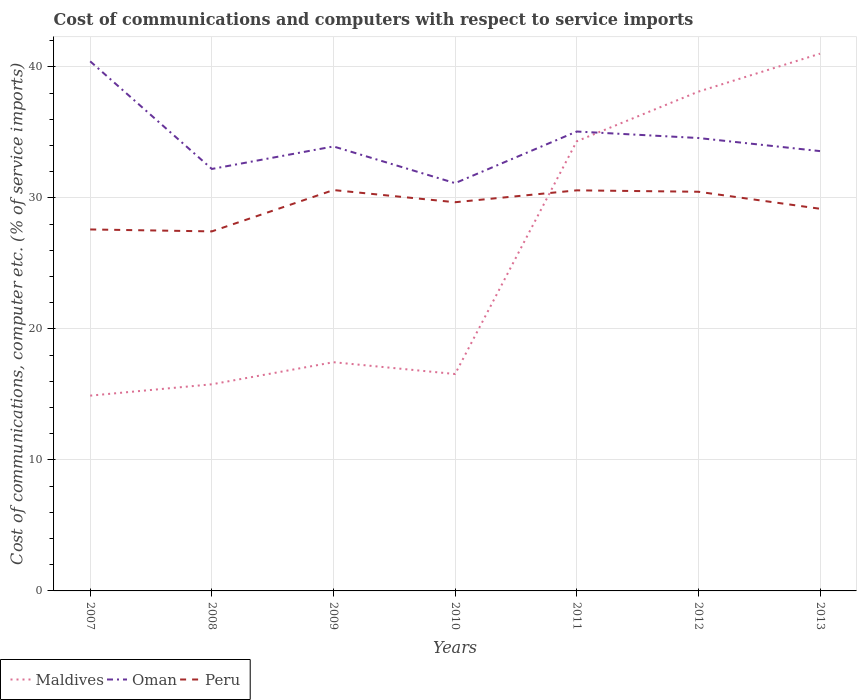Does the line corresponding to Oman intersect with the line corresponding to Maldives?
Offer a very short reply. Yes. Is the number of lines equal to the number of legend labels?
Provide a short and direct response. Yes. Across all years, what is the maximum cost of communications and computers in Oman?
Provide a succinct answer. 31.13. In which year was the cost of communications and computers in Peru maximum?
Keep it short and to the point. 2008. What is the total cost of communications and computers in Maldives in the graph?
Provide a succinct answer. -0.87. What is the difference between the highest and the second highest cost of communications and computers in Peru?
Provide a short and direct response. 3.16. What is the difference between the highest and the lowest cost of communications and computers in Peru?
Keep it short and to the point. 4. Is the cost of communications and computers in Oman strictly greater than the cost of communications and computers in Peru over the years?
Provide a succinct answer. No. How many years are there in the graph?
Offer a very short reply. 7. Does the graph contain grids?
Provide a succinct answer. Yes. Where does the legend appear in the graph?
Ensure brevity in your answer.  Bottom left. How are the legend labels stacked?
Give a very brief answer. Horizontal. What is the title of the graph?
Provide a succinct answer. Cost of communications and computers with respect to service imports. What is the label or title of the X-axis?
Your answer should be very brief. Years. What is the label or title of the Y-axis?
Provide a short and direct response. Cost of communications, computer etc. (% of service imports). What is the Cost of communications, computer etc. (% of service imports) in Maldives in 2007?
Your response must be concise. 14.91. What is the Cost of communications, computer etc. (% of service imports) in Oman in 2007?
Offer a very short reply. 40.43. What is the Cost of communications, computer etc. (% of service imports) of Peru in 2007?
Make the answer very short. 27.59. What is the Cost of communications, computer etc. (% of service imports) in Maldives in 2008?
Ensure brevity in your answer.  15.77. What is the Cost of communications, computer etc. (% of service imports) of Oman in 2008?
Ensure brevity in your answer.  32.21. What is the Cost of communications, computer etc. (% of service imports) in Peru in 2008?
Ensure brevity in your answer.  27.45. What is the Cost of communications, computer etc. (% of service imports) of Maldives in 2009?
Make the answer very short. 17.46. What is the Cost of communications, computer etc. (% of service imports) in Oman in 2009?
Your answer should be compact. 33.93. What is the Cost of communications, computer etc. (% of service imports) of Peru in 2009?
Your answer should be very brief. 30.6. What is the Cost of communications, computer etc. (% of service imports) of Maldives in 2010?
Keep it short and to the point. 16.56. What is the Cost of communications, computer etc. (% of service imports) in Oman in 2010?
Offer a terse response. 31.13. What is the Cost of communications, computer etc. (% of service imports) in Peru in 2010?
Make the answer very short. 29.67. What is the Cost of communications, computer etc. (% of service imports) in Maldives in 2011?
Your answer should be compact. 34.33. What is the Cost of communications, computer etc. (% of service imports) of Oman in 2011?
Your answer should be compact. 35.07. What is the Cost of communications, computer etc. (% of service imports) of Peru in 2011?
Provide a short and direct response. 30.58. What is the Cost of communications, computer etc. (% of service imports) of Maldives in 2012?
Offer a very short reply. 38.11. What is the Cost of communications, computer etc. (% of service imports) in Oman in 2012?
Offer a very short reply. 34.57. What is the Cost of communications, computer etc. (% of service imports) of Peru in 2012?
Make the answer very short. 30.47. What is the Cost of communications, computer etc. (% of service imports) of Maldives in 2013?
Offer a very short reply. 41.01. What is the Cost of communications, computer etc. (% of service imports) in Oman in 2013?
Ensure brevity in your answer.  33.58. What is the Cost of communications, computer etc. (% of service imports) of Peru in 2013?
Ensure brevity in your answer.  29.17. Across all years, what is the maximum Cost of communications, computer etc. (% of service imports) in Maldives?
Keep it short and to the point. 41.01. Across all years, what is the maximum Cost of communications, computer etc. (% of service imports) of Oman?
Your response must be concise. 40.43. Across all years, what is the maximum Cost of communications, computer etc. (% of service imports) of Peru?
Offer a terse response. 30.6. Across all years, what is the minimum Cost of communications, computer etc. (% of service imports) in Maldives?
Make the answer very short. 14.91. Across all years, what is the minimum Cost of communications, computer etc. (% of service imports) in Oman?
Give a very brief answer. 31.13. Across all years, what is the minimum Cost of communications, computer etc. (% of service imports) in Peru?
Your answer should be compact. 27.45. What is the total Cost of communications, computer etc. (% of service imports) in Maldives in the graph?
Your response must be concise. 178.15. What is the total Cost of communications, computer etc. (% of service imports) in Oman in the graph?
Ensure brevity in your answer.  240.92. What is the total Cost of communications, computer etc. (% of service imports) in Peru in the graph?
Ensure brevity in your answer.  205.54. What is the difference between the Cost of communications, computer etc. (% of service imports) of Maldives in 2007 and that in 2008?
Provide a short and direct response. -0.87. What is the difference between the Cost of communications, computer etc. (% of service imports) of Oman in 2007 and that in 2008?
Keep it short and to the point. 8.22. What is the difference between the Cost of communications, computer etc. (% of service imports) in Peru in 2007 and that in 2008?
Provide a short and direct response. 0.15. What is the difference between the Cost of communications, computer etc. (% of service imports) in Maldives in 2007 and that in 2009?
Provide a short and direct response. -2.55. What is the difference between the Cost of communications, computer etc. (% of service imports) in Oman in 2007 and that in 2009?
Offer a very short reply. 6.5. What is the difference between the Cost of communications, computer etc. (% of service imports) of Peru in 2007 and that in 2009?
Make the answer very short. -3.01. What is the difference between the Cost of communications, computer etc. (% of service imports) in Maldives in 2007 and that in 2010?
Keep it short and to the point. -1.65. What is the difference between the Cost of communications, computer etc. (% of service imports) in Oman in 2007 and that in 2010?
Offer a very short reply. 9.3. What is the difference between the Cost of communications, computer etc. (% of service imports) of Peru in 2007 and that in 2010?
Your response must be concise. -2.08. What is the difference between the Cost of communications, computer etc. (% of service imports) in Maldives in 2007 and that in 2011?
Keep it short and to the point. -19.42. What is the difference between the Cost of communications, computer etc. (% of service imports) in Oman in 2007 and that in 2011?
Give a very brief answer. 5.36. What is the difference between the Cost of communications, computer etc. (% of service imports) in Peru in 2007 and that in 2011?
Offer a terse response. -2.98. What is the difference between the Cost of communications, computer etc. (% of service imports) in Maldives in 2007 and that in 2012?
Keep it short and to the point. -23.21. What is the difference between the Cost of communications, computer etc. (% of service imports) of Oman in 2007 and that in 2012?
Ensure brevity in your answer.  5.85. What is the difference between the Cost of communications, computer etc. (% of service imports) of Peru in 2007 and that in 2012?
Keep it short and to the point. -2.88. What is the difference between the Cost of communications, computer etc. (% of service imports) of Maldives in 2007 and that in 2013?
Give a very brief answer. -26.11. What is the difference between the Cost of communications, computer etc. (% of service imports) of Oman in 2007 and that in 2013?
Offer a terse response. 6.85. What is the difference between the Cost of communications, computer etc. (% of service imports) in Peru in 2007 and that in 2013?
Your answer should be very brief. -1.58. What is the difference between the Cost of communications, computer etc. (% of service imports) in Maldives in 2008 and that in 2009?
Make the answer very short. -1.69. What is the difference between the Cost of communications, computer etc. (% of service imports) in Oman in 2008 and that in 2009?
Provide a short and direct response. -1.72. What is the difference between the Cost of communications, computer etc. (% of service imports) in Peru in 2008 and that in 2009?
Provide a short and direct response. -3.16. What is the difference between the Cost of communications, computer etc. (% of service imports) of Maldives in 2008 and that in 2010?
Ensure brevity in your answer.  -0.78. What is the difference between the Cost of communications, computer etc. (% of service imports) in Peru in 2008 and that in 2010?
Your response must be concise. -2.23. What is the difference between the Cost of communications, computer etc. (% of service imports) in Maldives in 2008 and that in 2011?
Offer a very short reply. -18.55. What is the difference between the Cost of communications, computer etc. (% of service imports) in Oman in 2008 and that in 2011?
Keep it short and to the point. -2.86. What is the difference between the Cost of communications, computer etc. (% of service imports) in Peru in 2008 and that in 2011?
Ensure brevity in your answer.  -3.13. What is the difference between the Cost of communications, computer etc. (% of service imports) in Maldives in 2008 and that in 2012?
Your answer should be very brief. -22.34. What is the difference between the Cost of communications, computer etc. (% of service imports) of Oman in 2008 and that in 2012?
Provide a short and direct response. -2.36. What is the difference between the Cost of communications, computer etc. (% of service imports) of Peru in 2008 and that in 2012?
Your answer should be compact. -3.03. What is the difference between the Cost of communications, computer etc. (% of service imports) of Maldives in 2008 and that in 2013?
Keep it short and to the point. -25.24. What is the difference between the Cost of communications, computer etc. (% of service imports) in Oman in 2008 and that in 2013?
Your response must be concise. -1.36. What is the difference between the Cost of communications, computer etc. (% of service imports) of Peru in 2008 and that in 2013?
Your answer should be compact. -1.73. What is the difference between the Cost of communications, computer etc. (% of service imports) in Maldives in 2009 and that in 2010?
Provide a succinct answer. 0.9. What is the difference between the Cost of communications, computer etc. (% of service imports) in Oman in 2009 and that in 2010?
Your response must be concise. 2.8. What is the difference between the Cost of communications, computer etc. (% of service imports) in Peru in 2009 and that in 2010?
Make the answer very short. 0.93. What is the difference between the Cost of communications, computer etc. (% of service imports) of Maldives in 2009 and that in 2011?
Your response must be concise. -16.87. What is the difference between the Cost of communications, computer etc. (% of service imports) in Oman in 2009 and that in 2011?
Your answer should be very brief. -1.14. What is the difference between the Cost of communications, computer etc. (% of service imports) of Peru in 2009 and that in 2011?
Provide a short and direct response. 0.02. What is the difference between the Cost of communications, computer etc. (% of service imports) in Maldives in 2009 and that in 2012?
Your response must be concise. -20.66. What is the difference between the Cost of communications, computer etc. (% of service imports) of Oman in 2009 and that in 2012?
Make the answer very short. -0.64. What is the difference between the Cost of communications, computer etc. (% of service imports) in Peru in 2009 and that in 2012?
Make the answer very short. 0.13. What is the difference between the Cost of communications, computer etc. (% of service imports) in Maldives in 2009 and that in 2013?
Ensure brevity in your answer.  -23.55. What is the difference between the Cost of communications, computer etc. (% of service imports) of Oman in 2009 and that in 2013?
Your response must be concise. 0.36. What is the difference between the Cost of communications, computer etc. (% of service imports) of Peru in 2009 and that in 2013?
Provide a succinct answer. 1.43. What is the difference between the Cost of communications, computer etc. (% of service imports) in Maldives in 2010 and that in 2011?
Offer a very short reply. -17.77. What is the difference between the Cost of communications, computer etc. (% of service imports) of Oman in 2010 and that in 2011?
Your answer should be compact. -3.94. What is the difference between the Cost of communications, computer etc. (% of service imports) of Peru in 2010 and that in 2011?
Offer a terse response. -0.91. What is the difference between the Cost of communications, computer etc. (% of service imports) in Maldives in 2010 and that in 2012?
Ensure brevity in your answer.  -21.56. What is the difference between the Cost of communications, computer etc. (% of service imports) of Oman in 2010 and that in 2012?
Offer a terse response. -3.45. What is the difference between the Cost of communications, computer etc. (% of service imports) in Peru in 2010 and that in 2012?
Your answer should be compact. -0.8. What is the difference between the Cost of communications, computer etc. (% of service imports) in Maldives in 2010 and that in 2013?
Ensure brevity in your answer.  -24.45. What is the difference between the Cost of communications, computer etc. (% of service imports) of Oman in 2010 and that in 2013?
Your response must be concise. -2.45. What is the difference between the Cost of communications, computer etc. (% of service imports) in Peru in 2010 and that in 2013?
Offer a terse response. 0.5. What is the difference between the Cost of communications, computer etc. (% of service imports) of Maldives in 2011 and that in 2012?
Provide a short and direct response. -3.79. What is the difference between the Cost of communications, computer etc. (% of service imports) in Oman in 2011 and that in 2012?
Keep it short and to the point. 0.5. What is the difference between the Cost of communications, computer etc. (% of service imports) of Peru in 2011 and that in 2012?
Your answer should be very brief. 0.11. What is the difference between the Cost of communications, computer etc. (% of service imports) of Maldives in 2011 and that in 2013?
Offer a very short reply. -6.69. What is the difference between the Cost of communications, computer etc. (% of service imports) in Oman in 2011 and that in 2013?
Ensure brevity in your answer.  1.49. What is the difference between the Cost of communications, computer etc. (% of service imports) in Peru in 2011 and that in 2013?
Your answer should be very brief. 1.41. What is the difference between the Cost of communications, computer etc. (% of service imports) in Maldives in 2012 and that in 2013?
Make the answer very short. -2.9. What is the difference between the Cost of communications, computer etc. (% of service imports) in Oman in 2012 and that in 2013?
Provide a short and direct response. 1. What is the difference between the Cost of communications, computer etc. (% of service imports) of Peru in 2012 and that in 2013?
Your answer should be compact. 1.3. What is the difference between the Cost of communications, computer etc. (% of service imports) of Maldives in 2007 and the Cost of communications, computer etc. (% of service imports) of Oman in 2008?
Your answer should be very brief. -17.3. What is the difference between the Cost of communications, computer etc. (% of service imports) of Maldives in 2007 and the Cost of communications, computer etc. (% of service imports) of Peru in 2008?
Offer a very short reply. -12.54. What is the difference between the Cost of communications, computer etc. (% of service imports) of Oman in 2007 and the Cost of communications, computer etc. (% of service imports) of Peru in 2008?
Make the answer very short. 12.98. What is the difference between the Cost of communications, computer etc. (% of service imports) of Maldives in 2007 and the Cost of communications, computer etc. (% of service imports) of Oman in 2009?
Your answer should be compact. -19.02. What is the difference between the Cost of communications, computer etc. (% of service imports) of Maldives in 2007 and the Cost of communications, computer etc. (% of service imports) of Peru in 2009?
Offer a very short reply. -15.69. What is the difference between the Cost of communications, computer etc. (% of service imports) of Oman in 2007 and the Cost of communications, computer etc. (% of service imports) of Peru in 2009?
Your answer should be compact. 9.83. What is the difference between the Cost of communications, computer etc. (% of service imports) in Maldives in 2007 and the Cost of communications, computer etc. (% of service imports) in Oman in 2010?
Keep it short and to the point. -16.22. What is the difference between the Cost of communications, computer etc. (% of service imports) in Maldives in 2007 and the Cost of communications, computer etc. (% of service imports) in Peru in 2010?
Make the answer very short. -14.76. What is the difference between the Cost of communications, computer etc. (% of service imports) in Oman in 2007 and the Cost of communications, computer etc. (% of service imports) in Peru in 2010?
Offer a terse response. 10.76. What is the difference between the Cost of communications, computer etc. (% of service imports) of Maldives in 2007 and the Cost of communications, computer etc. (% of service imports) of Oman in 2011?
Keep it short and to the point. -20.16. What is the difference between the Cost of communications, computer etc. (% of service imports) in Maldives in 2007 and the Cost of communications, computer etc. (% of service imports) in Peru in 2011?
Make the answer very short. -15.67. What is the difference between the Cost of communications, computer etc. (% of service imports) of Oman in 2007 and the Cost of communications, computer etc. (% of service imports) of Peru in 2011?
Your answer should be compact. 9.85. What is the difference between the Cost of communications, computer etc. (% of service imports) in Maldives in 2007 and the Cost of communications, computer etc. (% of service imports) in Oman in 2012?
Offer a terse response. -19.67. What is the difference between the Cost of communications, computer etc. (% of service imports) in Maldives in 2007 and the Cost of communications, computer etc. (% of service imports) in Peru in 2012?
Make the answer very short. -15.56. What is the difference between the Cost of communications, computer etc. (% of service imports) of Oman in 2007 and the Cost of communications, computer etc. (% of service imports) of Peru in 2012?
Provide a short and direct response. 9.96. What is the difference between the Cost of communications, computer etc. (% of service imports) of Maldives in 2007 and the Cost of communications, computer etc. (% of service imports) of Oman in 2013?
Keep it short and to the point. -18.67. What is the difference between the Cost of communications, computer etc. (% of service imports) in Maldives in 2007 and the Cost of communications, computer etc. (% of service imports) in Peru in 2013?
Give a very brief answer. -14.27. What is the difference between the Cost of communications, computer etc. (% of service imports) in Oman in 2007 and the Cost of communications, computer etc. (% of service imports) in Peru in 2013?
Offer a terse response. 11.26. What is the difference between the Cost of communications, computer etc. (% of service imports) of Maldives in 2008 and the Cost of communications, computer etc. (% of service imports) of Oman in 2009?
Make the answer very short. -18.16. What is the difference between the Cost of communications, computer etc. (% of service imports) in Maldives in 2008 and the Cost of communications, computer etc. (% of service imports) in Peru in 2009?
Ensure brevity in your answer.  -14.83. What is the difference between the Cost of communications, computer etc. (% of service imports) of Oman in 2008 and the Cost of communications, computer etc. (% of service imports) of Peru in 2009?
Make the answer very short. 1.61. What is the difference between the Cost of communications, computer etc. (% of service imports) of Maldives in 2008 and the Cost of communications, computer etc. (% of service imports) of Oman in 2010?
Provide a short and direct response. -15.36. What is the difference between the Cost of communications, computer etc. (% of service imports) of Maldives in 2008 and the Cost of communications, computer etc. (% of service imports) of Peru in 2010?
Make the answer very short. -13.9. What is the difference between the Cost of communications, computer etc. (% of service imports) of Oman in 2008 and the Cost of communications, computer etc. (% of service imports) of Peru in 2010?
Provide a short and direct response. 2.54. What is the difference between the Cost of communications, computer etc. (% of service imports) in Maldives in 2008 and the Cost of communications, computer etc. (% of service imports) in Oman in 2011?
Your answer should be very brief. -19.3. What is the difference between the Cost of communications, computer etc. (% of service imports) in Maldives in 2008 and the Cost of communications, computer etc. (% of service imports) in Peru in 2011?
Give a very brief answer. -14.81. What is the difference between the Cost of communications, computer etc. (% of service imports) of Oman in 2008 and the Cost of communications, computer etc. (% of service imports) of Peru in 2011?
Give a very brief answer. 1.63. What is the difference between the Cost of communications, computer etc. (% of service imports) of Maldives in 2008 and the Cost of communications, computer etc. (% of service imports) of Oman in 2012?
Your response must be concise. -18.8. What is the difference between the Cost of communications, computer etc. (% of service imports) in Maldives in 2008 and the Cost of communications, computer etc. (% of service imports) in Peru in 2012?
Your answer should be compact. -14.7. What is the difference between the Cost of communications, computer etc. (% of service imports) of Oman in 2008 and the Cost of communications, computer etc. (% of service imports) of Peru in 2012?
Provide a short and direct response. 1.74. What is the difference between the Cost of communications, computer etc. (% of service imports) of Maldives in 2008 and the Cost of communications, computer etc. (% of service imports) of Oman in 2013?
Your response must be concise. -17.8. What is the difference between the Cost of communications, computer etc. (% of service imports) in Maldives in 2008 and the Cost of communications, computer etc. (% of service imports) in Peru in 2013?
Give a very brief answer. -13.4. What is the difference between the Cost of communications, computer etc. (% of service imports) of Oman in 2008 and the Cost of communications, computer etc. (% of service imports) of Peru in 2013?
Your answer should be compact. 3.04. What is the difference between the Cost of communications, computer etc. (% of service imports) in Maldives in 2009 and the Cost of communications, computer etc. (% of service imports) in Oman in 2010?
Provide a short and direct response. -13.67. What is the difference between the Cost of communications, computer etc. (% of service imports) of Maldives in 2009 and the Cost of communications, computer etc. (% of service imports) of Peru in 2010?
Your answer should be very brief. -12.21. What is the difference between the Cost of communications, computer etc. (% of service imports) of Oman in 2009 and the Cost of communications, computer etc. (% of service imports) of Peru in 2010?
Give a very brief answer. 4.26. What is the difference between the Cost of communications, computer etc. (% of service imports) in Maldives in 2009 and the Cost of communications, computer etc. (% of service imports) in Oman in 2011?
Ensure brevity in your answer.  -17.61. What is the difference between the Cost of communications, computer etc. (% of service imports) of Maldives in 2009 and the Cost of communications, computer etc. (% of service imports) of Peru in 2011?
Ensure brevity in your answer.  -13.12. What is the difference between the Cost of communications, computer etc. (% of service imports) of Oman in 2009 and the Cost of communications, computer etc. (% of service imports) of Peru in 2011?
Keep it short and to the point. 3.35. What is the difference between the Cost of communications, computer etc. (% of service imports) in Maldives in 2009 and the Cost of communications, computer etc. (% of service imports) in Oman in 2012?
Provide a short and direct response. -17.12. What is the difference between the Cost of communications, computer etc. (% of service imports) in Maldives in 2009 and the Cost of communications, computer etc. (% of service imports) in Peru in 2012?
Offer a terse response. -13.01. What is the difference between the Cost of communications, computer etc. (% of service imports) in Oman in 2009 and the Cost of communications, computer etc. (% of service imports) in Peru in 2012?
Ensure brevity in your answer.  3.46. What is the difference between the Cost of communications, computer etc. (% of service imports) in Maldives in 2009 and the Cost of communications, computer etc. (% of service imports) in Oman in 2013?
Your response must be concise. -16.12. What is the difference between the Cost of communications, computer etc. (% of service imports) in Maldives in 2009 and the Cost of communications, computer etc. (% of service imports) in Peru in 2013?
Provide a succinct answer. -11.71. What is the difference between the Cost of communications, computer etc. (% of service imports) in Oman in 2009 and the Cost of communications, computer etc. (% of service imports) in Peru in 2013?
Make the answer very short. 4.76. What is the difference between the Cost of communications, computer etc. (% of service imports) in Maldives in 2010 and the Cost of communications, computer etc. (% of service imports) in Oman in 2011?
Offer a terse response. -18.51. What is the difference between the Cost of communications, computer etc. (% of service imports) in Maldives in 2010 and the Cost of communications, computer etc. (% of service imports) in Peru in 2011?
Provide a short and direct response. -14.02. What is the difference between the Cost of communications, computer etc. (% of service imports) of Oman in 2010 and the Cost of communications, computer etc. (% of service imports) of Peru in 2011?
Your answer should be compact. 0.55. What is the difference between the Cost of communications, computer etc. (% of service imports) of Maldives in 2010 and the Cost of communications, computer etc. (% of service imports) of Oman in 2012?
Make the answer very short. -18.02. What is the difference between the Cost of communications, computer etc. (% of service imports) in Maldives in 2010 and the Cost of communications, computer etc. (% of service imports) in Peru in 2012?
Keep it short and to the point. -13.91. What is the difference between the Cost of communications, computer etc. (% of service imports) in Oman in 2010 and the Cost of communications, computer etc. (% of service imports) in Peru in 2012?
Your response must be concise. 0.66. What is the difference between the Cost of communications, computer etc. (% of service imports) in Maldives in 2010 and the Cost of communications, computer etc. (% of service imports) in Oman in 2013?
Keep it short and to the point. -17.02. What is the difference between the Cost of communications, computer etc. (% of service imports) of Maldives in 2010 and the Cost of communications, computer etc. (% of service imports) of Peru in 2013?
Your answer should be very brief. -12.62. What is the difference between the Cost of communications, computer etc. (% of service imports) of Oman in 2010 and the Cost of communications, computer etc. (% of service imports) of Peru in 2013?
Offer a very short reply. 1.96. What is the difference between the Cost of communications, computer etc. (% of service imports) of Maldives in 2011 and the Cost of communications, computer etc. (% of service imports) of Oman in 2012?
Your answer should be very brief. -0.25. What is the difference between the Cost of communications, computer etc. (% of service imports) in Maldives in 2011 and the Cost of communications, computer etc. (% of service imports) in Peru in 2012?
Provide a succinct answer. 3.85. What is the difference between the Cost of communications, computer etc. (% of service imports) of Oman in 2011 and the Cost of communications, computer etc. (% of service imports) of Peru in 2012?
Your answer should be very brief. 4.6. What is the difference between the Cost of communications, computer etc. (% of service imports) of Maldives in 2011 and the Cost of communications, computer etc. (% of service imports) of Oman in 2013?
Offer a very short reply. 0.75. What is the difference between the Cost of communications, computer etc. (% of service imports) in Maldives in 2011 and the Cost of communications, computer etc. (% of service imports) in Peru in 2013?
Your answer should be compact. 5.15. What is the difference between the Cost of communications, computer etc. (% of service imports) in Oman in 2011 and the Cost of communications, computer etc. (% of service imports) in Peru in 2013?
Your answer should be compact. 5.9. What is the difference between the Cost of communications, computer etc. (% of service imports) of Maldives in 2012 and the Cost of communications, computer etc. (% of service imports) of Oman in 2013?
Provide a short and direct response. 4.54. What is the difference between the Cost of communications, computer etc. (% of service imports) in Maldives in 2012 and the Cost of communications, computer etc. (% of service imports) in Peru in 2013?
Offer a very short reply. 8.94. What is the difference between the Cost of communications, computer etc. (% of service imports) of Oman in 2012 and the Cost of communications, computer etc. (% of service imports) of Peru in 2013?
Provide a short and direct response. 5.4. What is the average Cost of communications, computer etc. (% of service imports) of Maldives per year?
Offer a very short reply. 25.45. What is the average Cost of communications, computer etc. (% of service imports) of Oman per year?
Your response must be concise. 34.42. What is the average Cost of communications, computer etc. (% of service imports) in Peru per year?
Your response must be concise. 29.36. In the year 2007, what is the difference between the Cost of communications, computer etc. (% of service imports) in Maldives and Cost of communications, computer etc. (% of service imports) in Oman?
Your answer should be compact. -25.52. In the year 2007, what is the difference between the Cost of communications, computer etc. (% of service imports) of Maldives and Cost of communications, computer etc. (% of service imports) of Peru?
Your response must be concise. -12.69. In the year 2007, what is the difference between the Cost of communications, computer etc. (% of service imports) in Oman and Cost of communications, computer etc. (% of service imports) in Peru?
Your response must be concise. 12.83. In the year 2008, what is the difference between the Cost of communications, computer etc. (% of service imports) in Maldives and Cost of communications, computer etc. (% of service imports) in Oman?
Your response must be concise. -16.44. In the year 2008, what is the difference between the Cost of communications, computer etc. (% of service imports) in Maldives and Cost of communications, computer etc. (% of service imports) in Peru?
Your response must be concise. -11.67. In the year 2008, what is the difference between the Cost of communications, computer etc. (% of service imports) in Oman and Cost of communications, computer etc. (% of service imports) in Peru?
Offer a terse response. 4.77. In the year 2009, what is the difference between the Cost of communications, computer etc. (% of service imports) in Maldives and Cost of communications, computer etc. (% of service imports) in Oman?
Keep it short and to the point. -16.47. In the year 2009, what is the difference between the Cost of communications, computer etc. (% of service imports) in Maldives and Cost of communications, computer etc. (% of service imports) in Peru?
Provide a short and direct response. -13.14. In the year 2009, what is the difference between the Cost of communications, computer etc. (% of service imports) in Oman and Cost of communications, computer etc. (% of service imports) in Peru?
Your answer should be compact. 3.33. In the year 2010, what is the difference between the Cost of communications, computer etc. (% of service imports) in Maldives and Cost of communications, computer etc. (% of service imports) in Oman?
Make the answer very short. -14.57. In the year 2010, what is the difference between the Cost of communications, computer etc. (% of service imports) of Maldives and Cost of communications, computer etc. (% of service imports) of Peru?
Provide a short and direct response. -13.11. In the year 2010, what is the difference between the Cost of communications, computer etc. (% of service imports) in Oman and Cost of communications, computer etc. (% of service imports) in Peru?
Your answer should be compact. 1.46. In the year 2011, what is the difference between the Cost of communications, computer etc. (% of service imports) in Maldives and Cost of communications, computer etc. (% of service imports) in Oman?
Make the answer very short. -0.74. In the year 2011, what is the difference between the Cost of communications, computer etc. (% of service imports) in Maldives and Cost of communications, computer etc. (% of service imports) in Peru?
Provide a succinct answer. 3.75. In the year 2011, what is the difference between the Cost of communications, computer etc. (% of service imports) in Oman and Cost of communications, computer etc. (% of service imports) in Peru?
Your response must be concise. 4.49. In the year 2012, what is the difference between the Cost of communications, computer etc. (% of service imports) of Maldives and Cost of communications, computer etc. (% of service imports) of Oman?
Provide a succinct answer. 3.54. In the year 2012, what is the difference between the Cost of communications, computer etc. (% of service imports) in Maldives and Cost of communications, computer etc. (% of service imports) in Peru?
Your response must be concise. 7.64. In the year 2012, what is the difference between the Cost of communications, computer etc. (% of service imports) in Oman and Cost of communications, computer etc. (% of service imports) in Peru?
Provide a succinct answer. 4.1. In the year 2013, what is the difference between the Cost of communications, computer etc. (% of service imports) in Maldives and Cost of communications, computer etc. (% of service imports) in Oman?
Provide a succinct answer. 7.44. In the year 2013, what is the difference between the Cost of communications, computer etc. (% of service imports) in Maldives and Cost of communications, computer etc. (% of service imports) in Peru?
Provide a short and direct response. 11.84. In the year 2013, what is the difference between the Cost of communications, computer etc. (% of service imports) in Oman and Cost of communications, computer etc. (% of service imports) in Peru?
Offer a very short reply. 4.4. What is the ratio of the Cost of communications, computer etc. (% of service imports) in Maldives in 2007 to that in 2008?
Your answer should be compact. 0.95. What is the ratio of the Cost of communications, computer etc. (% of service imports) in Oman in 2007 to that in 2008?
Provide a succinct answer. 1.26. What is the ratio of the Cost of communications, computer etc. (% of service imports) in Peru in 2007 to that in 2008?
Provide a succinct answer. 1.01. What is the ratio of the Cost of communications, computer etc. (% of service imports) of Maldives in 2007 to that in 2009?
Your answer should be compact. 0.85. What is the ratio of the Cost of communications, computer etc. (% of service imports) of Oman in 2007 to that in 2009?
Provide a succinct answer. 1.19. What is the ratio of the Cost of communications, computer etc. (% of service imports) of Peru in 2007 to that in 2009?
Keep it short and to the point. 0.9. What is the ratio of the Cost of communications, computer etc. (% of service imports) in Maldives in 2007 to that in 2010?
Your response must be concise. 0.9. What is the ratio of the Cost of communications, computer etc. (% of service imports) of Oman in 2007 to that in 2010?
Your response must be concise. 1.3. What is the ratio of the Cost of communications, computer etc. (% of service imports) in Peru in 2007 to that in 2010?
Keep it short and to the point. 0.93. What is the ratio of the Cost of communications, computer etc. (% of service imports) of Maldives in 2007 to that in 2011?
Make the answer very short. 0.43. What is the ratio of the Cost of communications, computer etc. (% of service imports) of Oman in 2007 to that in 2011?
Offer a very short reply. 1.15. What is the ratio of the Cost of communications, computer etc. (% of service imports) in Peru in 2007 to that in 2011?
Offer a terse response. 0.9. What is the ratio of the Cost of communications, computer etc. (% of service imports) of Maldives in 2007 to that in 2012?
Your response must be concise. 0.39. What is the ratio of the Cost of communications, computer etc. (% of service imports) in Oman in 2007 to that in 2012?
Make the answer very short. 1.17. What is the ratio of the Cost of communications, computer etc. (% of service imports) in Peru in 2007 to that in 2012?
Offer a terse response. 0.91. What is the ratio of the Cost of communications, computer etc. (% of service imports) in Maldives in 2007 to that in 2013?
Provide a succinct answer. 0.36. What is the ratio of the Cost of communications, computer etc. (% of service imports) in Oman in 2007 to that in 2013?
Ensure brevity in your answer.  1.2. What is the ratio of the Cost of communications, computer etc. (% of service imports) of Peru in 2007 to that in 2013?
Your answer should be compact. 0.95. What is the ratio of the Cost of communications, computer etc. (% of service imports) of Maldives in 2008 to that in 2009?
Give a very brief answer. 0.9. What is the ratio of the Cost of communications, computer etc. (% of service imports) of Oman in 2008 to that in 2009?
Keep it short and to the point. 0.95. What is the ratio of the Cost of communications, computer etc. (% of service imports) in Peru in 2008 to that in 2009?
Keep it short and to the point. 0.9. What is the ratio of the Cost of communications, computer etc. (% of service imports) of Maldives in 2008 to that in 2010?
Offer a terse response. 0.95. What is the ratio of the Cost of communications, computer etc. (% of service imports) in Oman in 2008 to that in 2010?
Offer a very short reply. 1.03. What is the ratio of the Cost of communications, computer etc. (% of service imports) in Peru in 2008 to that in 2010?
Provide a short and direct response. 0.93. What is the ratio of the Cost of communications, computer etc. (% of service imports) of Maldives in 2008 to that in 2011?
Ensure brevity in your answer.  0.46. What is the ratio of the Cost of communications, computer etc. (% of service imports) in Oman in 2008 to that in 2011?
Offer a very short reply. 0.92. What is the ratio of the Cost of communications, computer etc. (% of service imports) of Peru in 2008 to that in 2011?
Provide a short and direct response. 0.9. What is the ratio of the Cost of communications, computer etc. (% of service imports) in Maldives in 2008 to that in 2012?
Give a very brief answer. 0.41. What is the ratio of the Cost of communications, computer etc. (% of service imports) in Oman in 2008 to that in 2012?
Give a very brief answer. 0.93. What is the ratio of the Cost of communications, computer etc. (% of service imports) of Peru in 2008 to that in 2012?
Your answer should be very brief. 0.9. What is the ratio of the Cost of communications, computer etc. (% of service imports) of Maldives in 2008 to that in 2013?
Make the answer very short. 0.38. What is the ratio of the Cost of communications, computer etc. (% of service imports) in Oman in 2008 to that in 2013?
Make the answer very short. 0.96. What is the ratio of the Cost of communications, computer etc. (% of service imports) of Peru in 2008 to that in 2013?
Offer a very short reply. 0.94. What is the ratio of the Cost of communications, computer etc. (% of service imports) in Maldives in 2009 to that in 2010?
Provide a short and direct response. 1.05. What is the ratio of the Cost of communications, computer etc. (% of service imports) in Oman in 2009 to that in 2010?
Give a very brief answer. 1.09. What is the ratio of the Cost of communications, computer etc. (% of service imports) in Peru in 2009 to that in 2010?
Make the answer very short. 1.03. What is the ratio of the Cost of communications, computer etc. (% of service imports) in Maldives in 2009 to that in 2011?
Your response must be concise. 0.51. What is the ratio of the Cost of communications, computer etc. (% of service imports) in Oman in 2009 to that in 2011?
Your response must be concise. 0.97. What is the ratio of the Cost of communications, computer etc. (% of service imports) in Peru in 2009 to that in 2011?
Offer a terse response. 1. What is the ratio of the Cost of communications, computer etc. (% of service imports) of Maldives in 2009 to that in 2012?
Your answer should be very brief. 0.46. What is the ratio of the Cost of communications, computer etc. (% of service imports) of Oman in 2009 to that in 2012?
Give a very brief answer. 0.98. What is the ratio of the Cost of communications, computer etc. (% of service imports) in Peru in 2009 to that in 2012?
Your answer should be very brief. 1. What is the ratio of the Cost of communications, computer etc. (% of service imports) in Maldives in 2009 to that in 2013?
Your response must be concise. 0.43. What is the ratio of the Cost of communications, computer etc. (% of service imports) in Oman in 2009 to that in 2013?
Offer a very short reply. 1.01. What is the ratio of the Cost of communications, computer etc. (% of service imports) in Peru in 2009 to that in 2013?
Keep it short and to the point. 1.05. What is the ratio of the Cost of communications, computer etc. (% of service imports) of Maldives in 2010 to that in 2011?
Keep it short and to the point. 0.48. What is the ratio of the Cost of communications, computer etc. (% of service imports) in Oman in 2010 to that in 2011?
Your answer should be compact. 0.89. What is the ratio of the Cost of communications, computer etc. (% of service imports) of Peru in 2010 to that in 2011?
Provide a succinct answer. 0.97. What is the ratio of the Cost of communications, computer etc. (% of service imports) in Maldives in 2010 to that in 2012?
Provide a short and direct response. 0.43. What is the ratio of the Cost of communications, computer etc. (% of service imports) of Oman in 2010 to that in 2012?
Your response must be concise. 0.9. What is the ratio of the Cost of communications, computer etc. (% of service imports) of Peru in 2010 to that in 2012?
Give a very brief answer. 0.97. What is the ratio of the Cost of communications, computer etc. (% of service imports) in Maldives in 2010 to that in 2013?
Provide a short and direct response. 0.4. What is the ratio of the Cost of communications, computer etc. (% of service imports) in Oman in 2010 to that in 2013?
Give a very brief answer. 0.93. What is the ratio of the Cost of communications, computer etc. (% of service imports) of Peru in 2010 to that in 2013?
Your answer should be compact. 1.02. What is the ratio of the Cost of communications, computer etc. (% of service imports) of Maldives in 2011 to that in 2012?
Your answer should be compact. 0.9. What is the ratio of the Cost of communications, computer etc. (% of service imports) of Oman in 2011 to that in 2012?
Provide a short and direct response. 1.01. What is the ratio of the Cost of communications, computer etc. (% of service imports) of Maldives in 2011 to that in 2013?
Offer a very short reply. 0.84. What is the ratio of the Cost of communications, computer etc. (% of service imports) of Oman in 2011 to that in 2013?
Your answer should be very brief. 1.04. What is the ratio of the Cost of communications, computer etc. (% of service imports) in Peru in 2011 to that in 2013?
Provide a short and direct response. 1.05. What is the ratio of the Cost of communications, computer etc. (% of service imports) in Maldives in 2012 to that in 2013?
Keep it short and to the point. 0.93. What is the ratio of the Cost of communications, computer etc. (% of service imports) in Oman in 2012 to that in 2013?
Provide a short and direct response. 1.03. What is the ratio of the Cost of communications, computer etc. (% of service imports) of Peru in 2012 to that in 2013?
Your response must be concise. 1.04. What is the difference between the highest and the second highest Cost of communications, computer etc. (% of service imports) of Maldives?
Ensure brevity in your answer.  2.9. What is the difference between the highest and the second highest Cost of communications, computer etc. (% of service imports) of Oman?
Provide a succinct answer. 5.36. What is the difference between the highest and the second highest Cost of communications, computer etc. (% of service imports) of Peru?
Your answer should be compact. 0.02. What is the difference between the highest and the lowest Cost of communications, computer etc. (% of service imports) in Maldives?
Provide a succinct answer. 26.11. What is the difference between the highest and the lowest Cost of communications, computer etc. (% of service imports) of Oman?
Offer a terse response. 9.3. What is the difference between the highest and the lowest Cost of communications, computer etc. (% of service imports) of Peru?
Give a very brief answer. 3.16. 